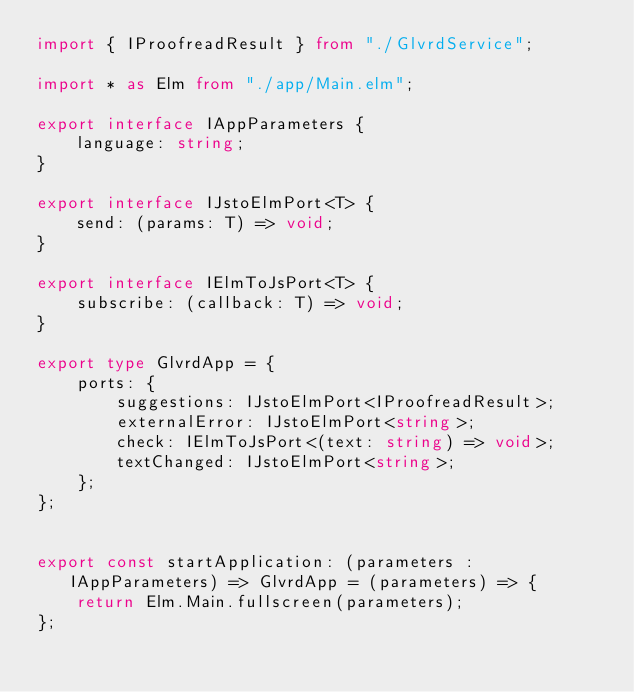Convert code to text. <code><loc_0><loc_0><loc_500><loc_500><_TypeScript_>import { IProofreadResult } from "./GlvrdService";

import * as Elm from "./app/Main.elm";

export interface IAppParameters {
    language: string;
}

export interface IJstoElmPort<T> {
    send: (params: T) => void;
}

export interface IElmToJsPort<T> {
    subscribe: (callback: T) => void;
}

export type GlvrdApp = {
    ports: {
        suggestions: IJstoElmPort<IProofreadResult>;
        externalError: IJstoElmPort<string>;
        check: IElmToJsPort<(text: string) => void>;
        textChanged: IJstoElmPort<string>;
    };
};


export const startApplication: (parameters : IAppParameters) => GlvrdApp = (parameters) => {
    return Elm.Main.fullscreen(parameters);
};
</code> 